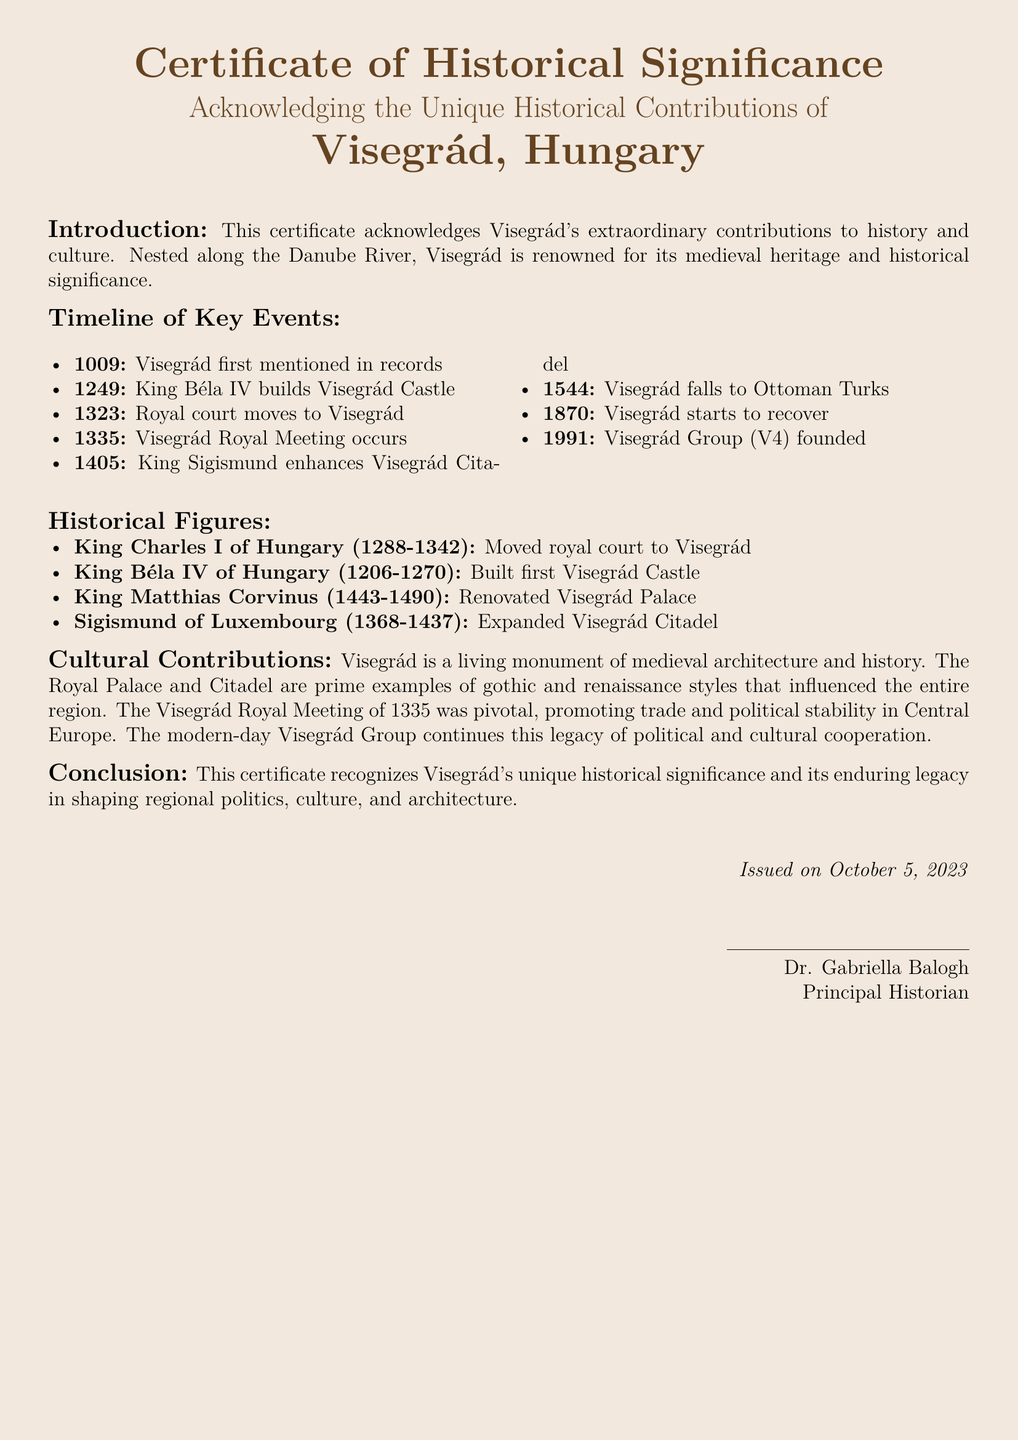What year was Visegrád first mentioned in records? The document notes that Visegrád was first mentioned in records in 1009.
Answer: 1009 Who built the first Visegrád Castle? According to the document, it was King Béla IV of Hungary who built the first Visegrád Castle in 1249.
Answer: King Béla IV of Hungary What significant event occurred in 1335 in Visegrád? The document states that the Visegrád Royal Meeting occurred in 1335.
Answer: Visegrád Royal Meeting Which historical figure renovated Visegrád Palace? King Matthias Corvinus is noted in the document as having renovated the Visegrád Palace.
Answer: King Matthias Corvinus What color is used for the document's section titles? The section titles are presented in dark brown color as specified in the document.
Answer: dark brown What was a major cultural contribution of Visegrád mentioned in the document? The document mentions that Visegrád is a living monument of medieval architecture and history.
Answer: medieval architecture How many key events are listed in the timeline? There are a total of eight key events listed in the timeline in the document.
Answer: eight Who issued the certificate? The certificate was issued by Dr. Gabriella Balogh, as noted at the bottom of the document.
Answer: Dr. Gabriella Balogh What is the significance of the year 1991 for Visegrád? The document states that the Visegrád Group (V4) was founded in 1991.
Answer: Visegrád Group (V4) 